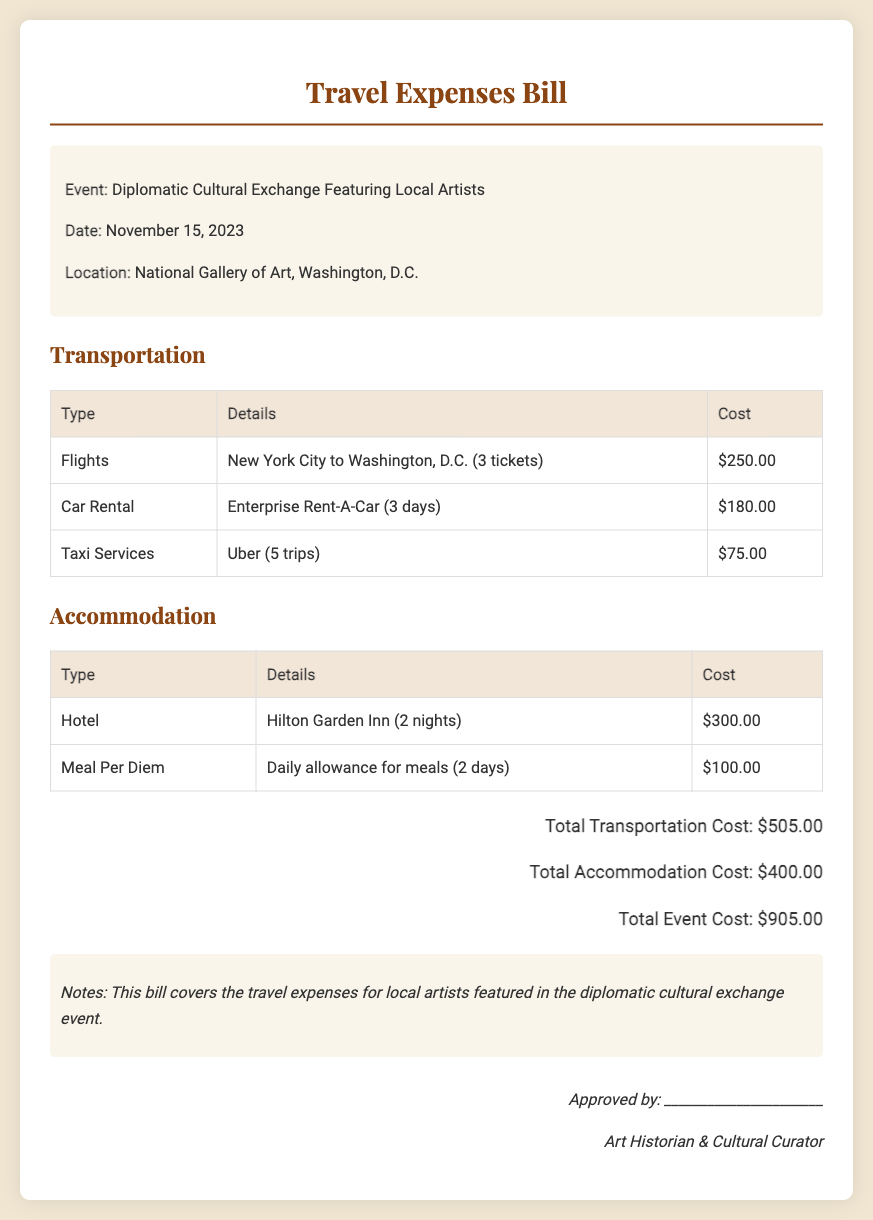what is the event date? The event date is specified in the document.
Answer: November 15, 2023 where is the event located? The document states the location of the event.
Answer: National Gallery of Art, Washington, D.C how many tickets were purchased for flights? The document provides the number of tickets purchased.
Answer: 3 tickets what is the total cost for transportation? The total cost for transportation is highlighted at the end of the transportation section.
Answer: $505.00 how much is allocated for meal per diem? The document specifies the cost noted for meal per diem.
Answer: $100.00 what is the total cost for the event? The total event cost is summarized at the end of the document.
Answer: $905.00 which hotel provided accommodation? The document mentions the name of the hotel for accommodation.
Answer: Hilton Garden Inn how many nights were spent at the hotel? The document indicates the number of nights for accommodation.
Answer: 2 nights who is responsible for approving the expenses? The document includes a signature line for the approver.
Answer: Art Historian & Cultural Curator 